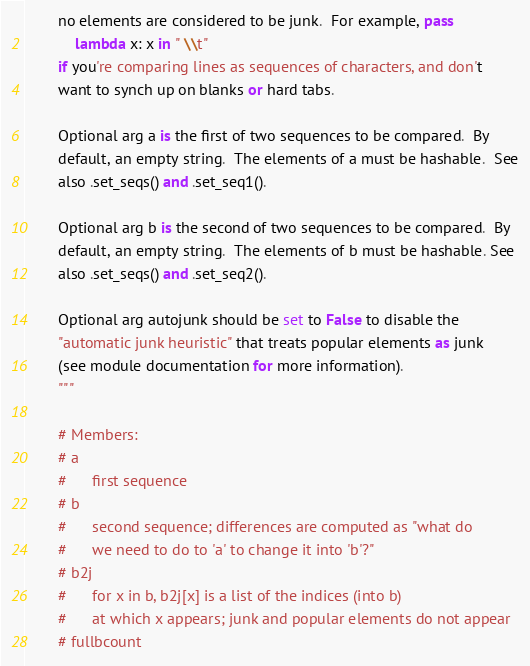Convert code to text. <code><loc_0><loc_0><loc_500><loc_500><_Python_>        no elements are considered to be junk.  For example, pass
            lambda x: x in " \\t"
        if you're comparing lines as sequences of characters, and don't
        want to synch up on blanks or hard tabs.

        Optional arg a is the first of two sequences to be compared.  By
        default, an empty string.  The elements of a must be hashable.  See
        also .set_seqs() and .set_seq1().

        Optional arg b is the second of two sequences to be compared.  By
        default, an empty string.  The elements of b must be hashable. See
        also .set_seqs() and .set_seq2().

        Optional arg autojunk should be set to False to disable the
        "automatic junk heuristic" that treats popular elements as junk
        (see module documentation for more information).
        """

        # Members:
        # a
        #      first sequence
        # b
        #      second sequence; differences are computed as "what do
        #      we need to do to 'a' to change it into 'b'?"
        # b2j
        #      for x in b, b2j[x] is a list of the indices (into b)
        #      at which x appears; junk and popular elements do not appear
        # fullbcount</code> 